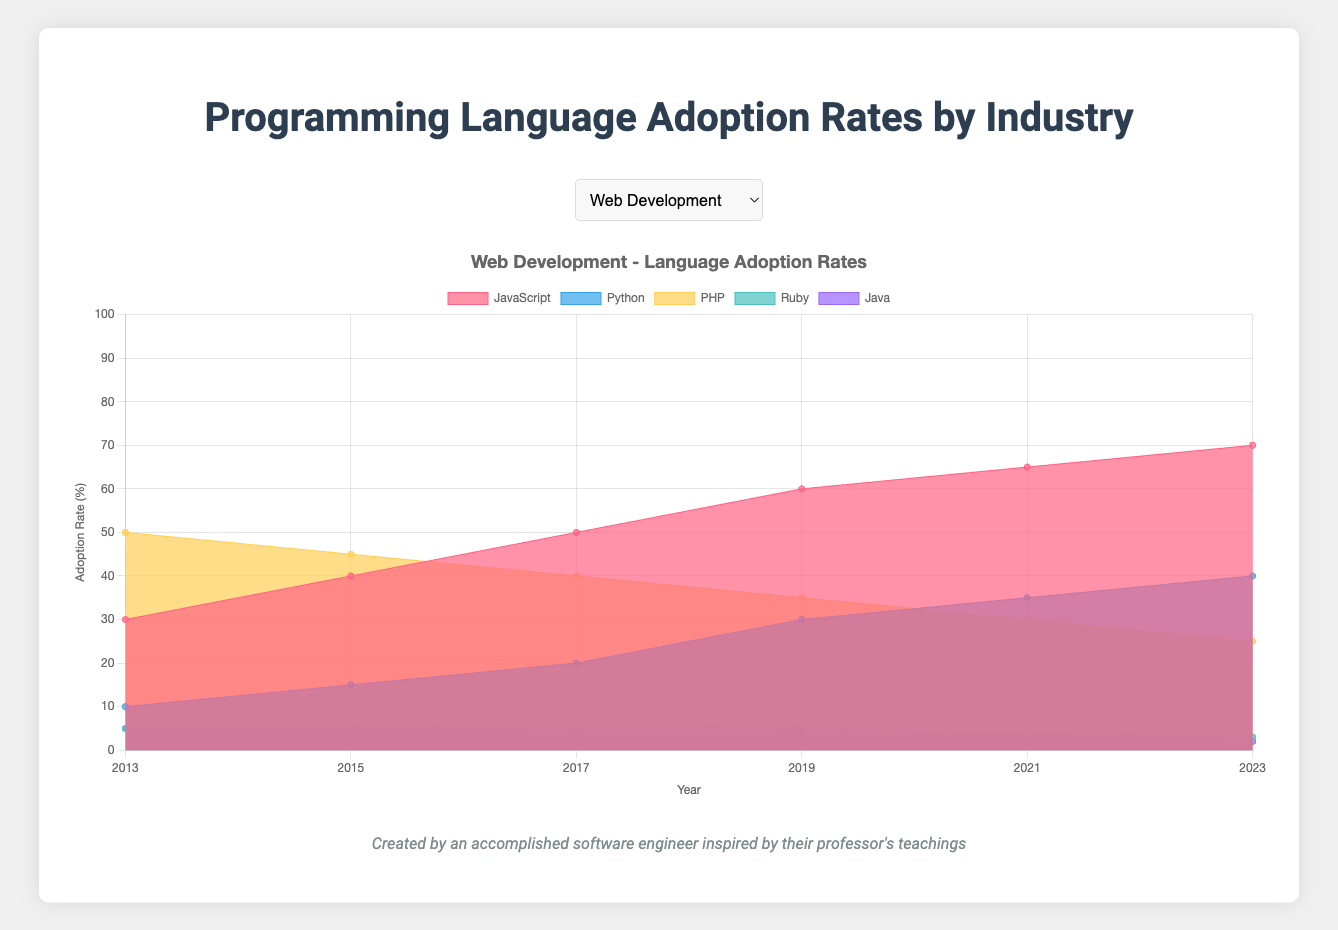Which programming language has the highest adoption rate in Data Science in 2023? To determine the programming language with the highest adoption rate in Data Science in 2023, look at the 2023 column for the Data Science industry and identify the highest value. In this case, Python has the highest value at 75%.
Answer: Python How has the adoption rate of JavaScript in Web Development changed from 2013 to 2023? To see the change in JavaScript adoption rate in Web Development over the years, subtract its 2013 rate (30%) from its 2023 rate (70%).
Answer: Increased by 40% What is the average adoption rate of Kotlin in Mobile Development from 2017 to 2023? Find the sum of Kotlin's adoption rates from 2017 (10%), 2019 (15%), 2021 (20%), and 2023 (25%); then divide by the number of years. (10 + 15 + 20 + 25) / 4 = 70 / 4 = 17.5
Answer: 17.5% In which year did PHP's adoption rate in Web Development first decrease below 40%? Observe the trend of PHP's adoption rate in Web Development; the first time it falls below 40% is in 2017.
Answer: 2017 Compare the adoption rates of Python and Java in Enterprise Software in 2023. Which one is higher? Look at the 2023 column for Enterprise Software to compare Python (18%) and Java (53%). Python has the lower value compared to Java.
Answer: Java By how many percentage points did Swift’s adoption rate in Mobile Development increase between 2013 and 2023? Calculate the rise in Swift’s adoption rate by subtracting the 2013 value (10%) from the 2023 value (50%).
Answer: 40 percentage points How does the adoption rate of C++ in Game Development in 2023 compare to its adoption rate in Embedded Systems in 2023? Compare the values of C++ for both industries in 2023: 42% in Game Development and 37% in Embedded Systems. C++ has a higher rate in Game Development.
Answer: Game Development What is the overall trend of R's adoption rate in Data Science from 2013 to 2023? To find the overall trend, note the values: 2013 (40%), 2015 (35%), 2017 (30%), 2019 (25%), 2021 (20%), and 2023 (15%). The trend shows a consistent decline.
Answer: Decreasing Which programming language in Embedded Systems has shown significant growth from 2013 to 2023? Examine the changes, and Python shows an increase from 0% in 2013 to 10% in 2023, indicating significant growth. Rust, increasing from 0% to 5%, also shows notable growth but not as significant.
Answer: Python For which industry did Python's adoption rate see the highest increase between 2013 and 2023? Compare the difference in Python's adoption rates across all industries. Data Science shows the largest increase from 50% to 75%, a 25% increase.
Answer: Data Science 